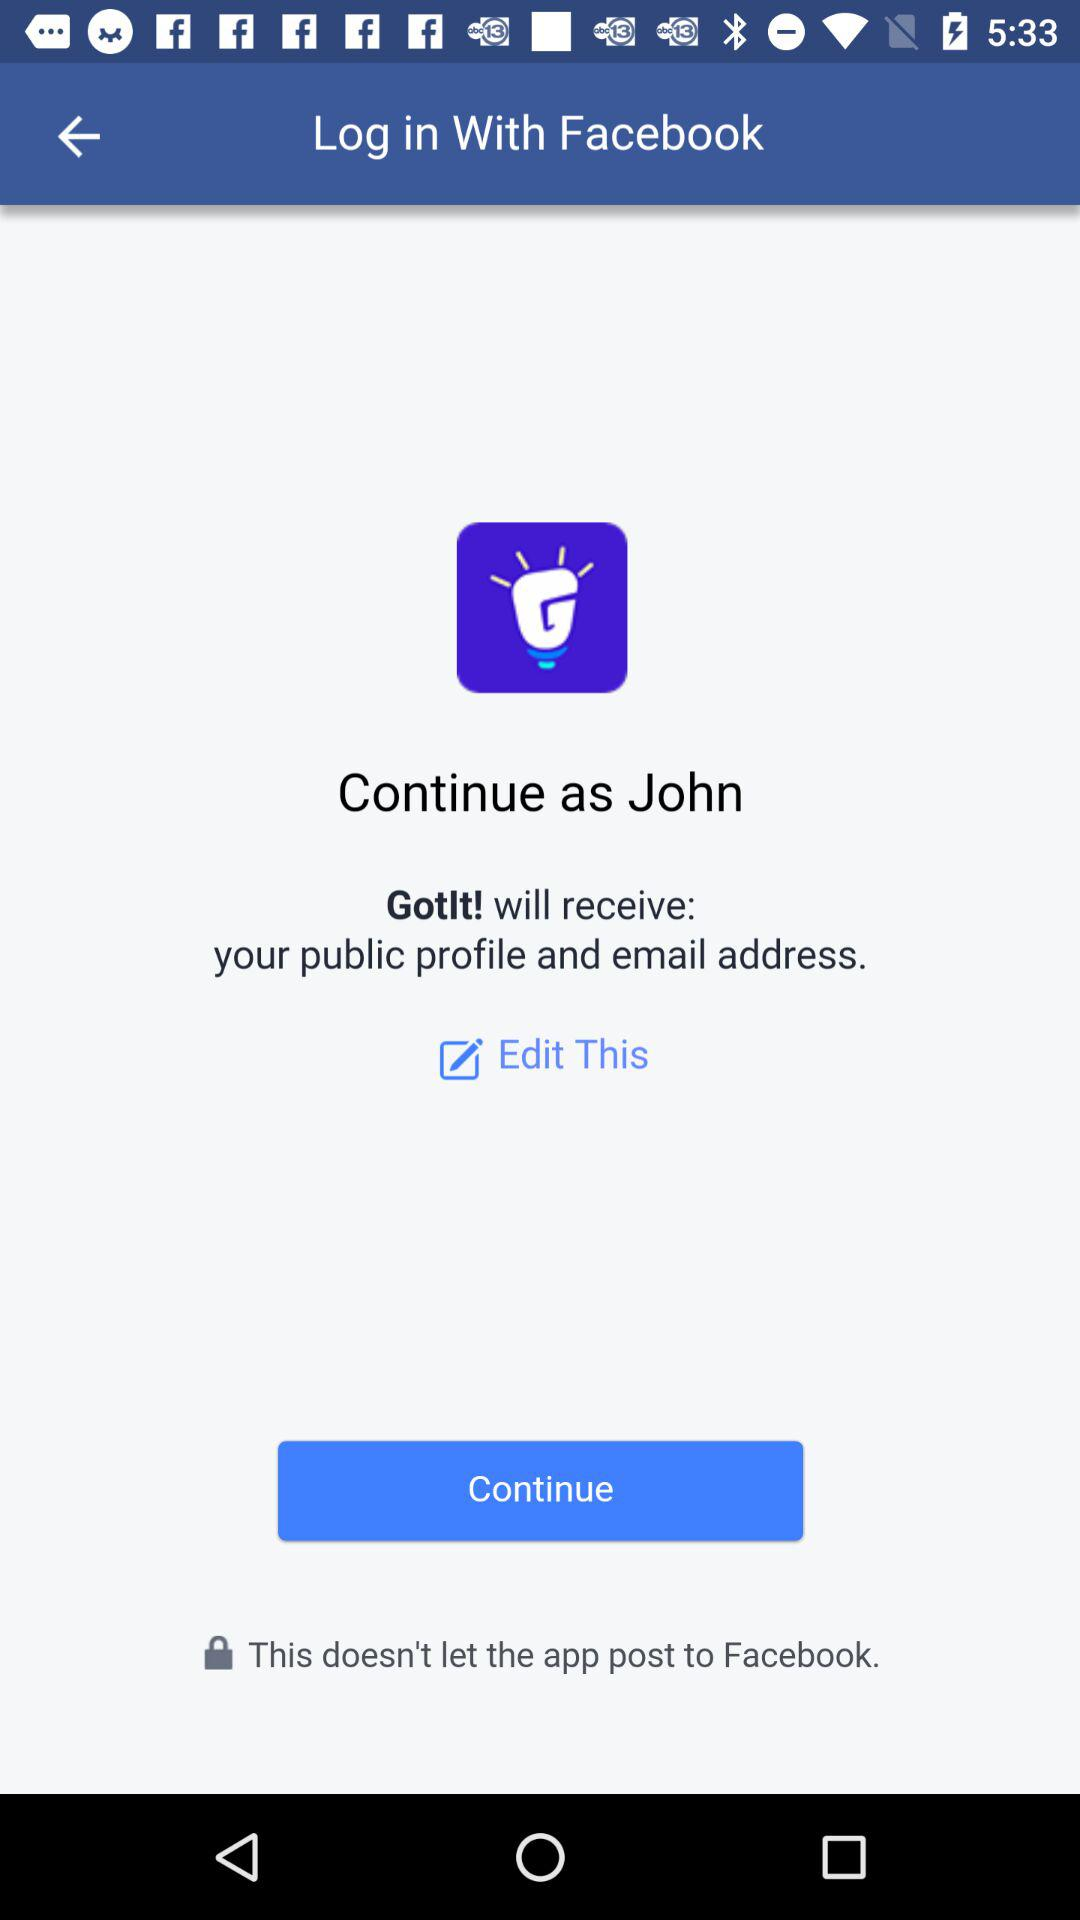What is the application through which a user can log in? The user can log in through "Facebook". 